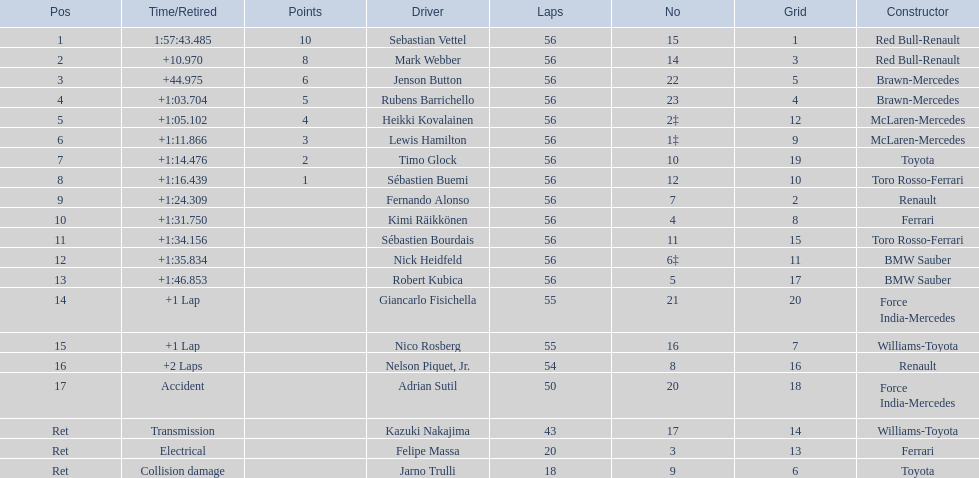Which drivers raced in the 2009 chinese grand prix? Sebastian Vettel, Mark Webber, Jenson Button, Rubens Barrichello, Heikki Kovalainen, Lewis Hamilton, Timo Glock, Sébastien Buemi, Fernando Alonso, Kimi Räikkönen, Sébastien Bourdais, Nick Heidfeld, Robert Kubica, Giancarlo Fisichella, Nico Rosberg, Nelson Piquet, Jr., Adrian Sutil, Kazuki Nakajima, Felipe Massa, Jarno Trulli. Of the drivers in the 2009 chinese grand prix, which finished the race? Sebastian Vettel, Mark Webber, Jenson Button, Rubens Barrichello, Heikki Kovalainen, Lewis Hamilton, Timo Glock, Sébastien Buemi, Fernando Alonso, Kimi Räikkönen, Sébastien Bourdais, Nick Heidfeld, Robert Kubica. Of the drivers who finished the race, who had the slowest time? Robert Kubica. 